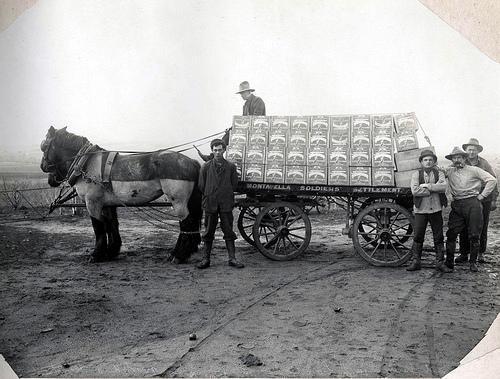How many people are in the photo?
Give a very brief answer. 3. 